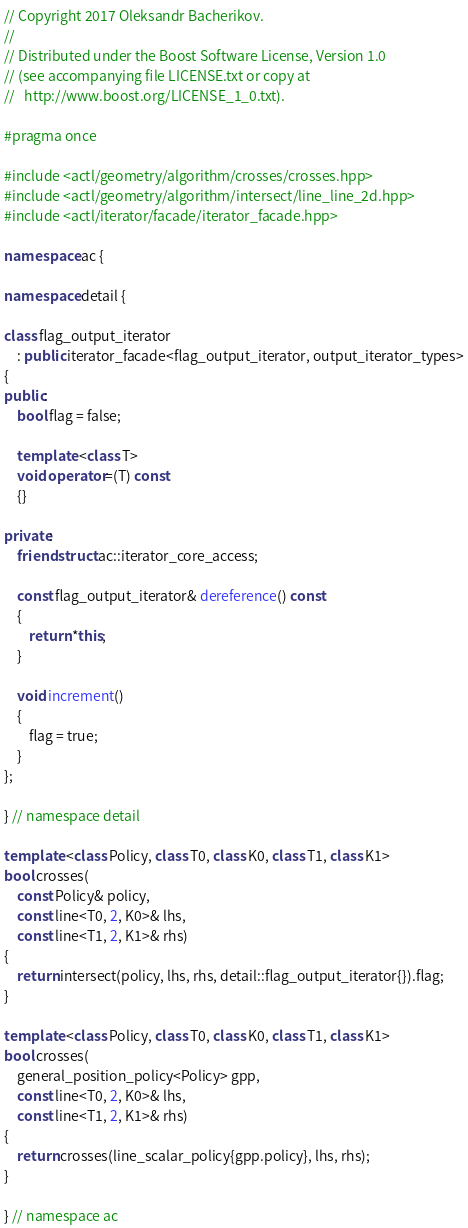<code> <loc_0><loc_0><loc_500><loc_500><_C++_>// Copyright 2017 Oleksandr Bacherikov.
//
// Distributed under the Boost Software License, Version 1.0
// (see accompanying file LICENSE.txt or copy at
//   http://www.boost.org/LICENSE_1_0.txt).

#pragma once

#include <actl/geometry/algorithm/crosses/crosses.hpp>
#include <actl/geometry/algorithm/intersect/line_line_2d.hpp>
#include <actl/iterator/facade/iterator_facade.hpp>

namespace ac {

namespace detail {

class flag_output_iterator
    : public iterator_facade<flag_output_iterator, output_iterator_types>
{
public:
    bool flag = false;

    template <class T>
    void operator=(T) const
    {}

private:
    friend struct ac::iterator_core_access;

    const flag_output_iterator& dereference() const
    {
        return *this;
    }

    void increment()
    {
        flag = true;
    }
};

} // namespace detail

template <class Policy, class T0, class K0, class T1, class K1>
bool crosses(
    const Policy& policy,
    const line<T0, 2, K0>& lhs,
    const line<T1, 2, K1>& rhs)
{
    return intersect(policy, lhs, rhs, detail::flag_output_iterator{}).flag;
}

template <class Policy, class T0, class K0, class T1, class K1>
bool crosses(
    general_position_policy<Policy> gpp,
    const line<T0, 2, K0>& lhs,
    const line<T1, 2, K1>& rhs)
{
    return crosses(line_scalar_policy{gpp.policy}, lhs, rhs);
}

} // namespace ac
</code> 